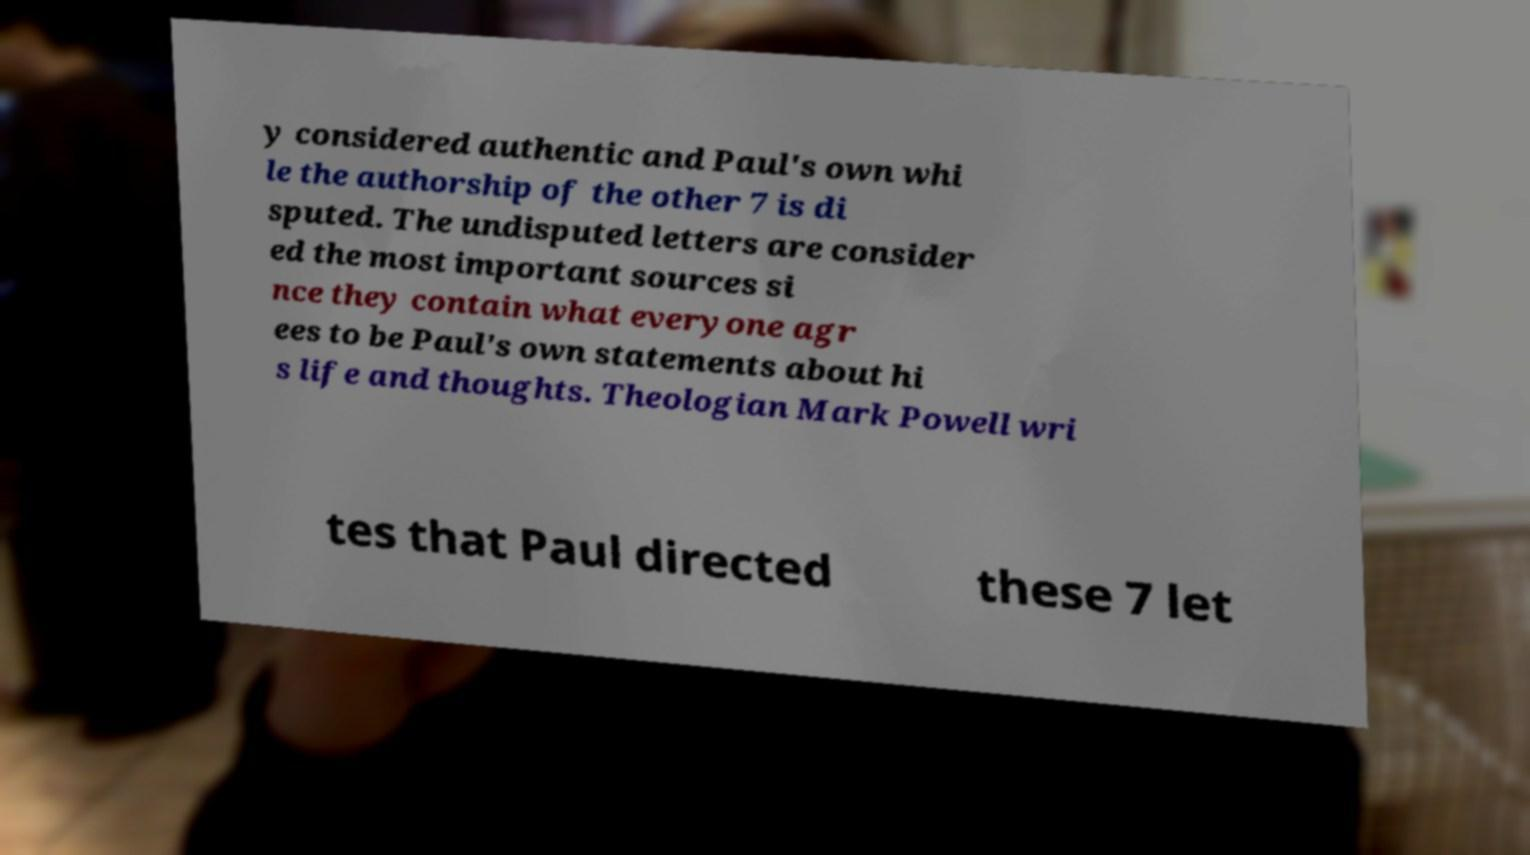Please identify and transcribe the text found in this image. y considered authentic and Paul's own whi le the authorship of the other 7 is di sputed. The undisputed letters are consider ed the most important sources si nce they contain what everyone agr ees to be Paul's own statements about hi s life and thoughts. Theologian Mark Powell wri tes that Paul directed these 7 let 